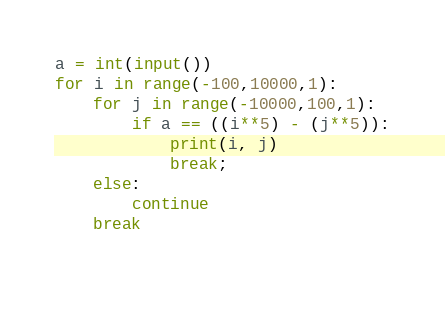Convert code to text. <code><loc_0><loc_0><loc_500><loc_500><_Python_>a = int(input())
for i in range(-100,10000,1):
    for j in range(-10000,100,1):
        if a == ((i**5) - (j**5)):
            print(i, j)
            break;
    else:
        continue
    break
        
</code> 